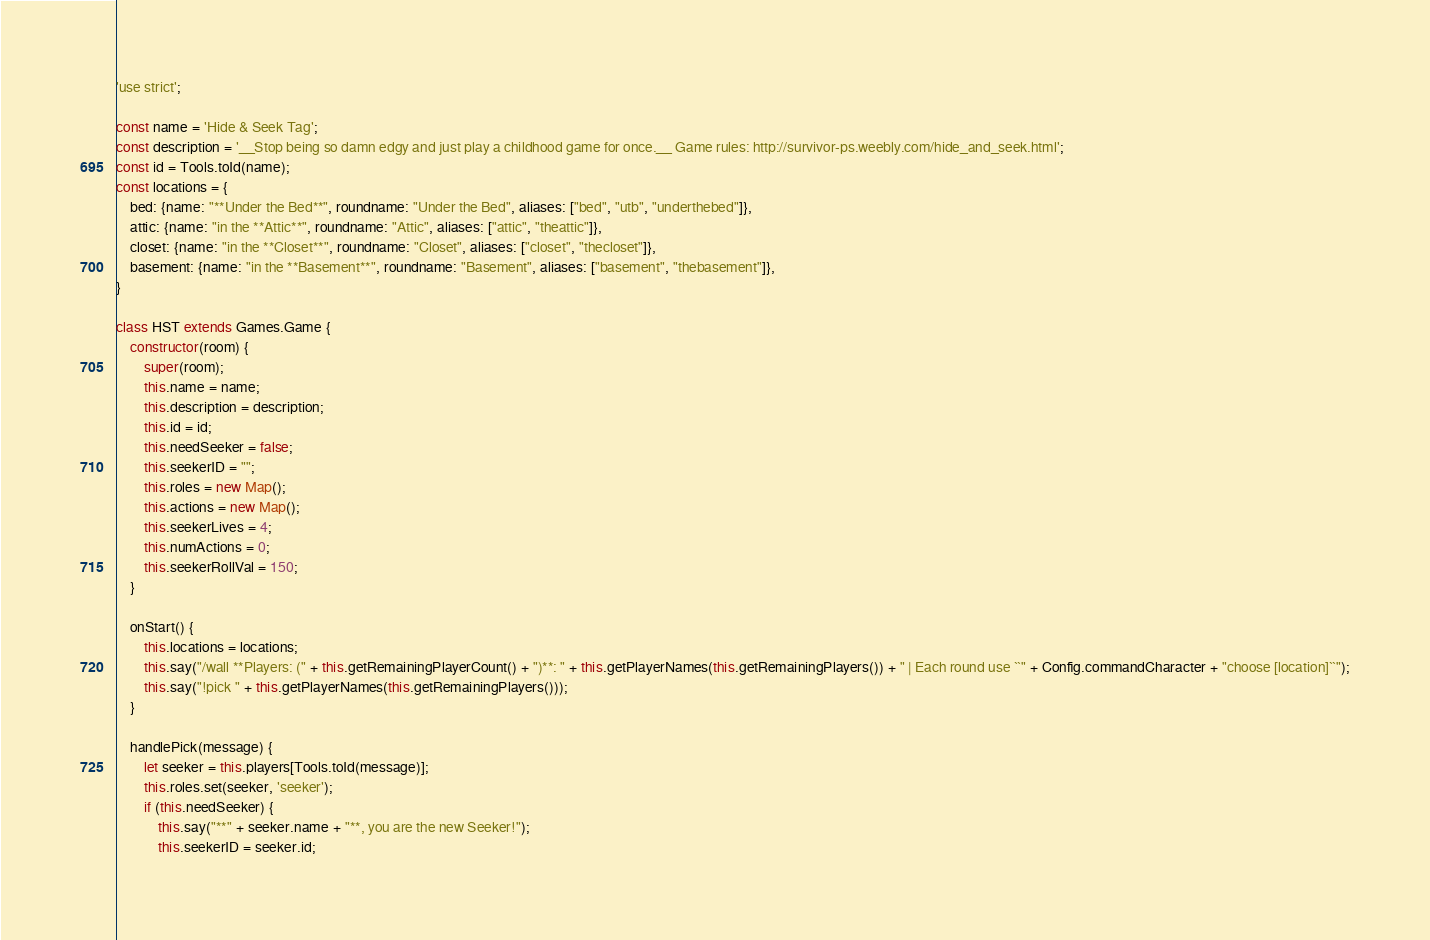<code> <loc_0><loc_0><loc_500><loc_500><_JavaScript_>'use strict';

const name = 'Hide & Seek Tag';
const description = '__Stop being so damn edgy and just play a childhood game for once.__ Game rules: http://survivor-ps.weebly.com/hide_and_seek.html';
const id = Tools.toId(name);
const locations = {
	bed: {name: "**Under the Bed**", roundname: "Under the Bed", aliases: ["bed", "utb", "underthebed"]},
	attic: {name: "in the **Attic**", roundname: "Attic", aliases: ["attic", "theattic"]},
	closet: {name: "in the **Closet**", roundname: "Closet", aliases: ["closet", "thecloset"]},
	basement: {name: "in the **Basement**", roundname: "Basement", aliases: ["basement", "thebasement"]},
}

class HST extends Games.Game {
	constructor(room) {
		super(room);
		this.name = name;
		this.description = description;
		this.id = id;
		this.needSeeker = false;
		this.seekerID = "";
		this.roles = new Map();
		this.actions = new Map();
		this.seekerLives = 4;
		this.numActions = 0;
		this.seekerRollVal = 150;
	}

	onStart() {
		this.locations = locations;
		this.say("/wall **Players: (" + this.getRemainingPlayerCount() + ")**: " + this.getPlayerNames(this.getRemainingPlayers()) + " | Each round use ``" + Config.commandCharacter + "choose [location]``");
		this.say("!pick " + this.getPlayerNames(this.getRemainingPlayers()));
	}

	handlePick(message) {
		let seeker = this.players[Tools.toId(message)];
		this.roles.set(seeker, 'seeker');
		if (this.needSeeker) {
			this.say("**" + seeker.name + "**, you are the new Seeker!");
			this.seekerID = seeker.id;</code> 